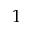Convert formula to latex. <formula><loc_0><loc_0><loc_500><loc_500>1</formula> 